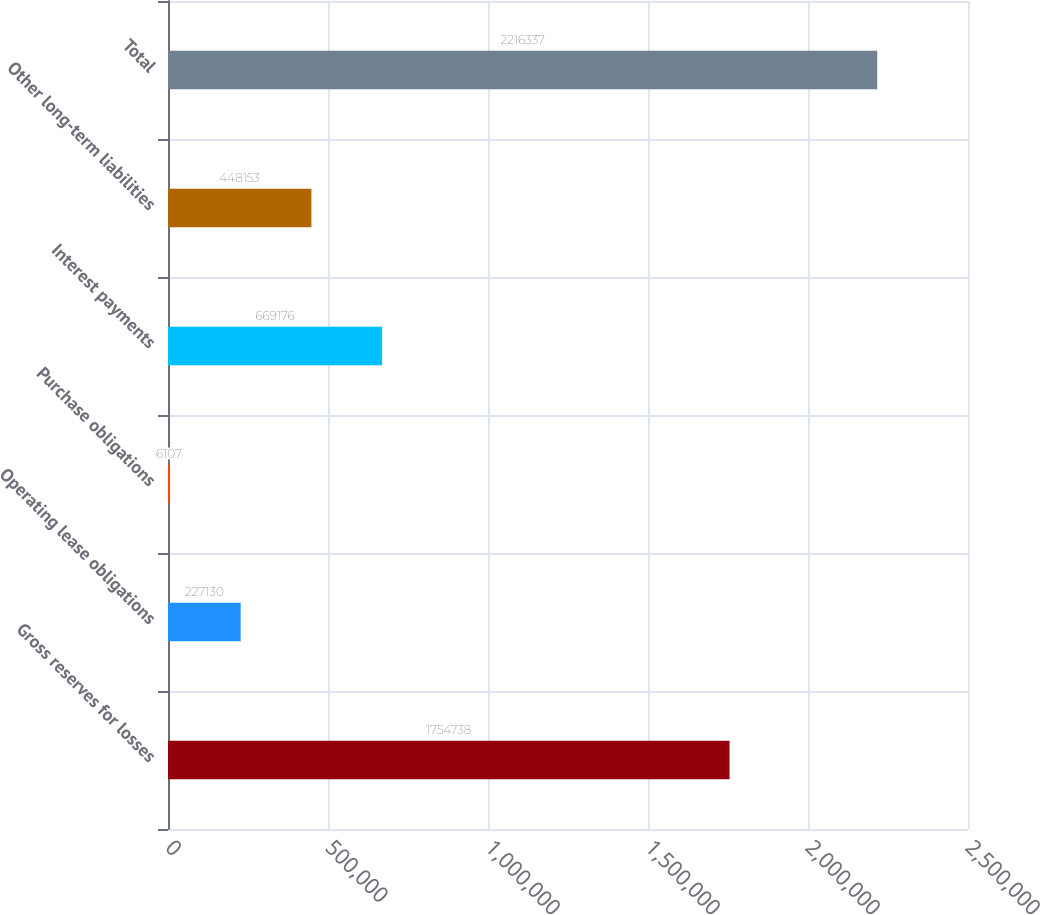Convert chart. <chart><loc_0><loc_0><loc_500><loc_500><bar_chart><fcel>Gross reserves for losses<fcel>Operating lease obligations<fcel>Purchase obligations<fcel>Interest payments<fcel>Other long-term liabilities<fcel>Total<nl><fcel>1.75474e+06<fcel>227130<fcel>6107<fcel>669176<fcel>448153<fcel>2.21634e+06<nl></chart> 